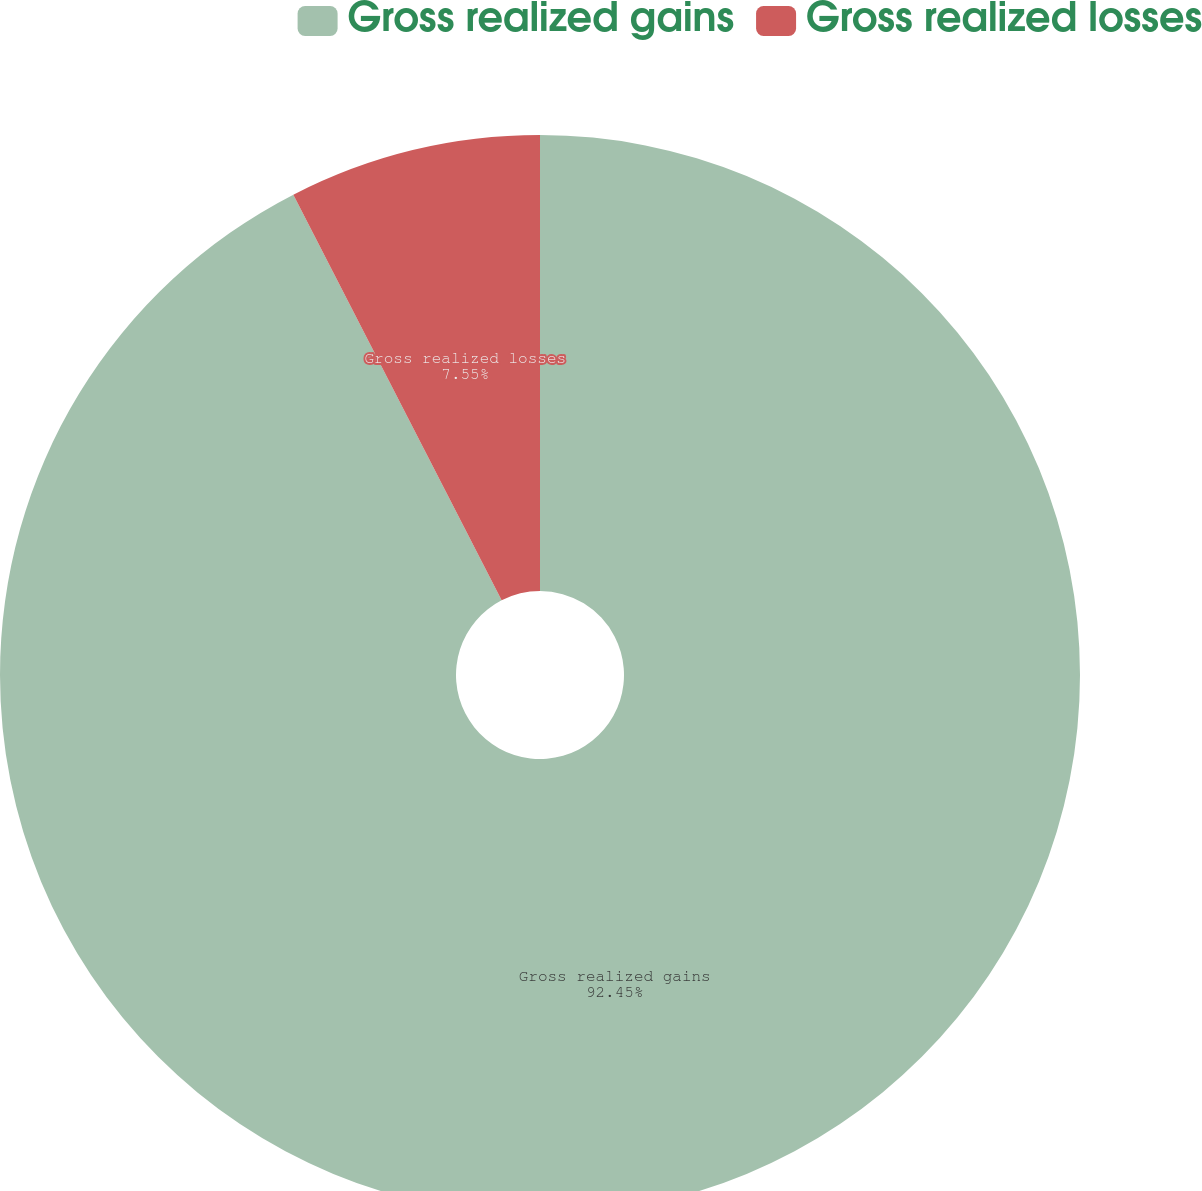Convert chart. <chart><loc_0><loc_0><loc_500><loc_500><pie_chart><fcel>Gross realized gains<fcel>Gross realized losses<nl><fcel>92.45%<fcel>7.55%<nl></chart> 